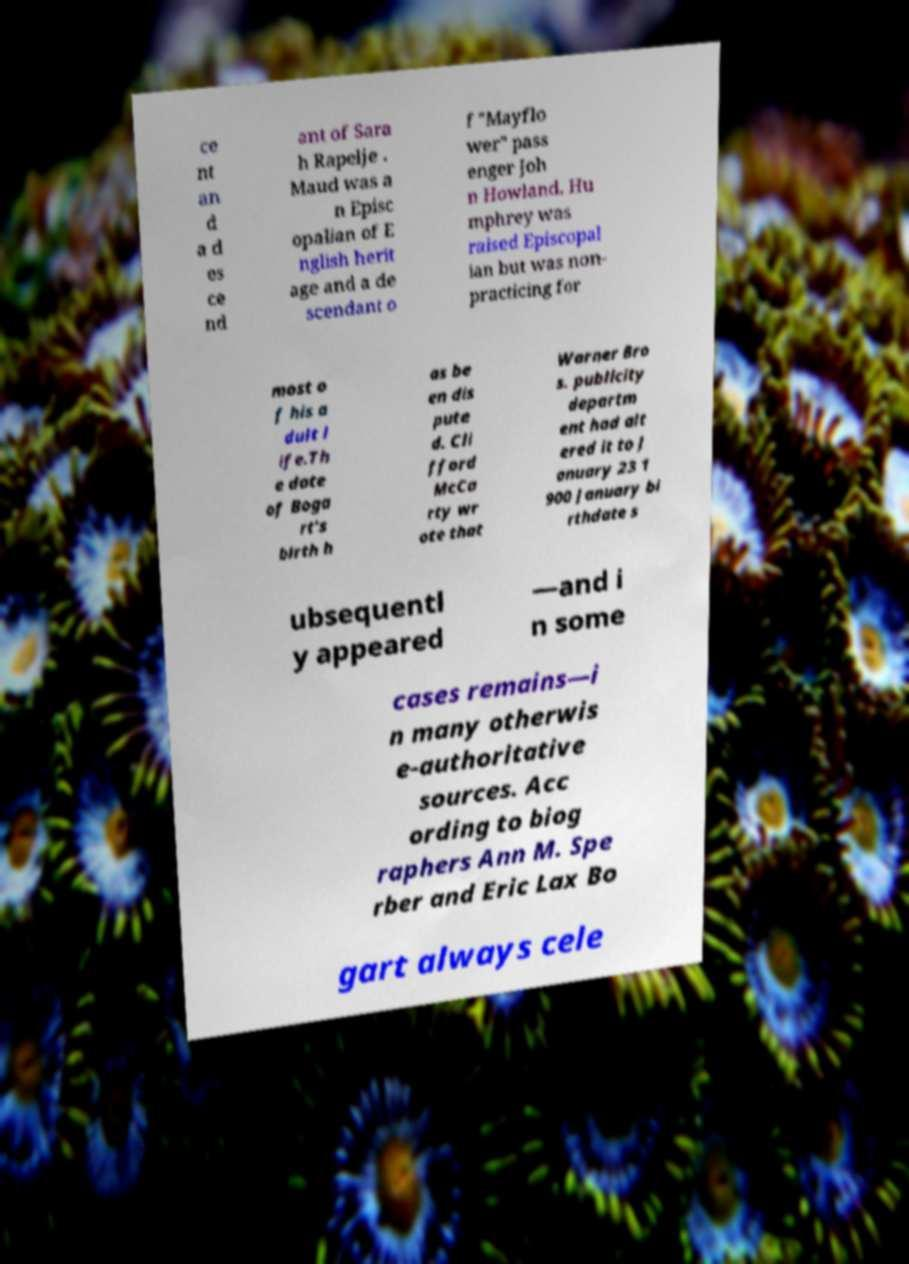Please read and relay the text visible in this image. What does it say? ce nt an d a d es ce nd ant of Sara h Rapelje . Maud was a n Episc opalian of E nglish herit age and a de scendant o f "Mayflo wer" pass enger Joh n Howland. Hu mphrey was raised Episcopal ian but was non- practicing for most o f his a dult l ife.Th e date of Boga rt's birth h as be en dis pute d. Cli fford McCa rty wr ote that Warner Bro s. publicity departm ent had alt ered it to J anuary 23 1 900 January bi rthdate s ubsequentl y appeared —and i n some cases remains—i n many otherwis e-authoritative sources. Acc ording to biog raphers Ann M. Spe rber and Eric Lax Bo gart always cele 